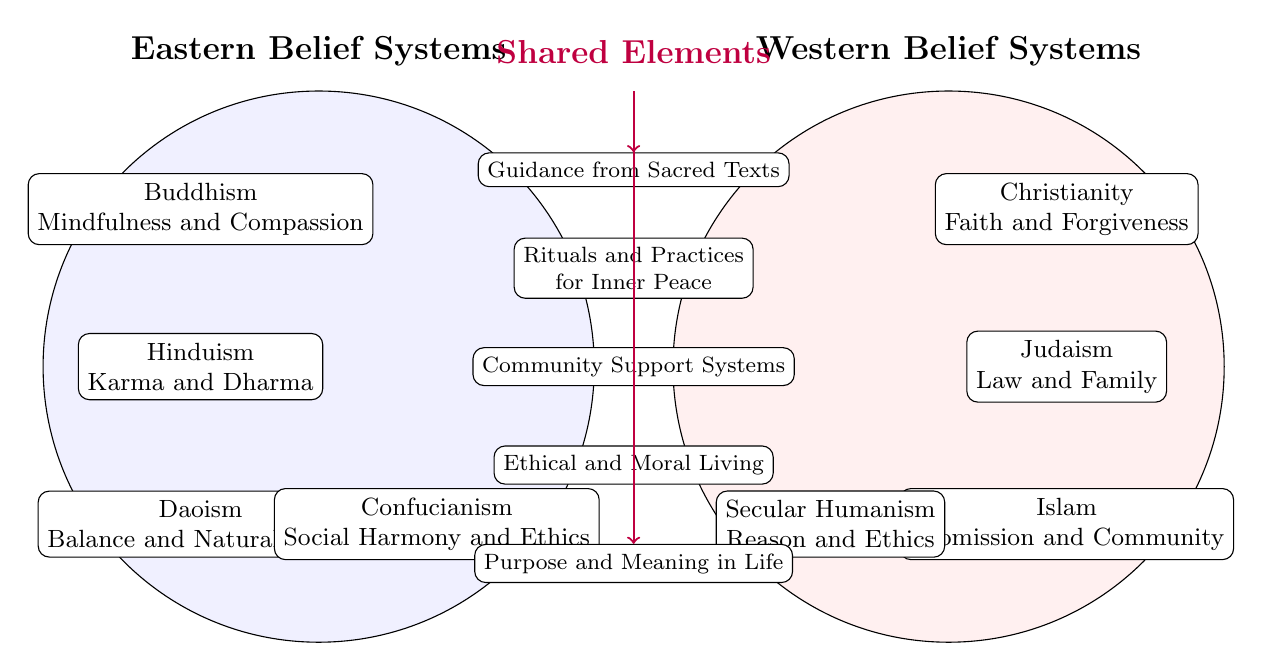What are the elements of Buddhism listed in the diagram? The diagram lists "Mindfulness and Compassion" as the element of Buddhism under Eastern Belief Systems, which is found in the left circle.
Answer: Mindfulness and Compassion How many Eastern belief systems are represented in the diagram? The left circle contains four elements of Eastern belief systems: Buddhism, Hinduism, Daoism, and Confucianism. Counting these gives a total of four.
Answer: 4 What shared element focuses on ethical living? The shared element that relates to ethical living is labeled "Ethical and Moral Living," which is located in the overlapping section of the two belief systems.
Answer: Ethical and Moral Living What is the key aspect of Christianity in the diagram? The diagram shows "Faith and Forgiveness" under Christianity in the right circle representing Western Belief Systems.
Answer: Faith and Forgiveness Which belief system is associated with "Karma and Dharma"? "Karma and Dharma" is the belief system associated with Hinduism, which is listed in the Eastern Belief Systems section of the diagram.
Answer: Hinduism What do the shared elements between the belief systems indicate? The shared elements such as "Community Support Systems" and "Purpose and Meaning in Life" show commonalities between Eastern and Western belief systems, suggesting that despite differences, there are universal factors contributing to mental well-being.
Answer: Commonalities How many elements are in the Western belief systems section of the diagram? There are four distinct elements listed in the Western belief systems circle: Christianity, Judaism, Islam, and Secular Humanism. Counting these elements totals to four.
Answer: 4 What shared element is found at the center of the diagram? The central shared element labeled "Community Support Systems" indicates this commonality that exists in both Eastern and Western beliefs about mental well-being.
Answer: Community Support Systems What is the significance of the arrows pointing to the shared elements? The arrows pointing to the shared elements indicate that these elements are influenced or guided by both Eastern and Western beliefs, emphasizing their importance for mental well-being across cultures.
Answer: Influence of both beliefs 